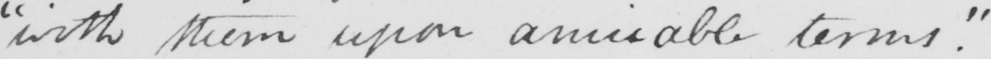Please provide the text content of this handwritten line. " with them upon amicable terms . " 